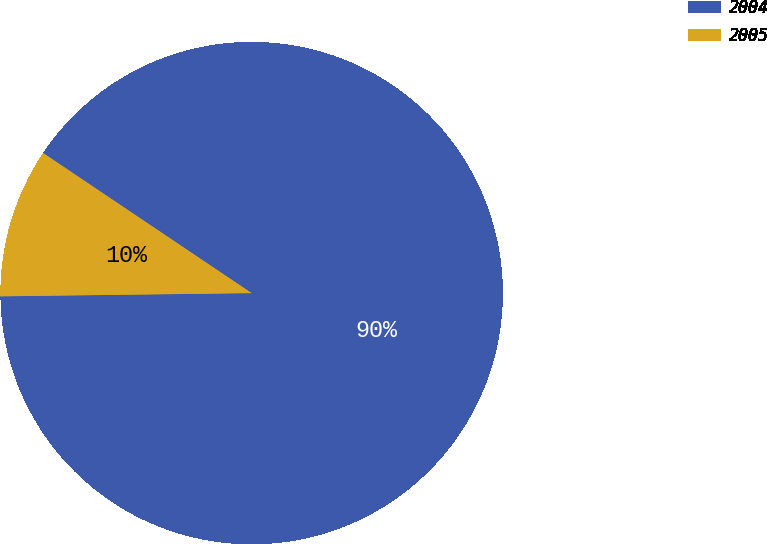<chart> <loc_0><loc_0><loc_500><loc_500><pie_chart><fcel>2004<fcel>2005<nl><fcel>90.38%<fcel>9.62%<nl></chart> 